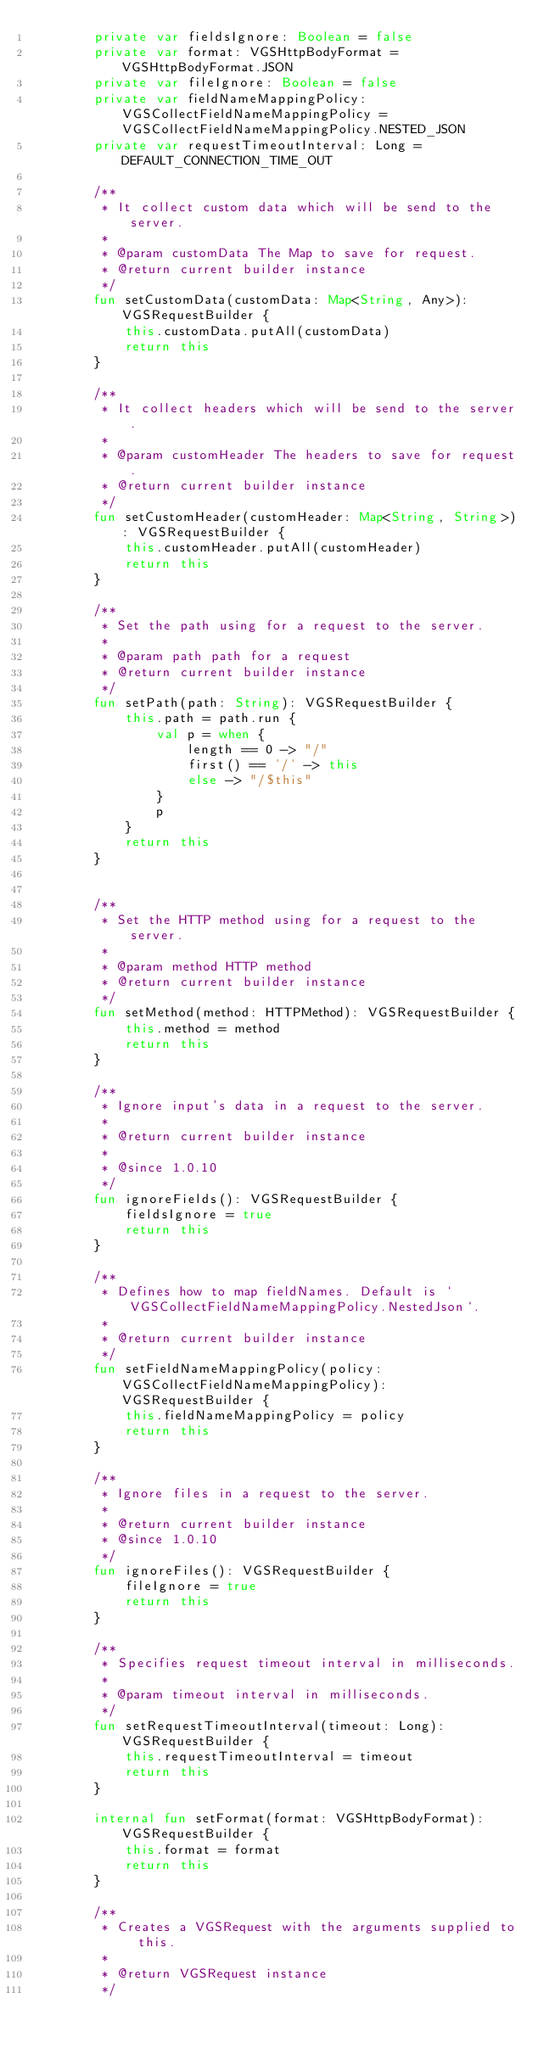Convert code to text. <code><loc_0><loc_0><loc_500><loc_500><_Kotlin_>        private var fieldsIgnore: Boolean = false
        private var format: VGSHttpBodyFormat = VGSHttpBodyFormat.JSON
        private var fileIgnore: Boolean = false
        private var fieldNameMappingPolicy: VGSCollectFieldNameMappingPolicy = VGSCollectFieldNameMappingPolicy.NESTED_JSON
        private var requestTimeoutInterval: Long = DEFAULT_CONNECTION_TIME_OUT

        /**
         * It collect custom data which will be send to the server.
         *
         * @param customData The Map to save for request.
         * @return current builder instance
         */
        fun setCustomData(customData: Map<String, Any>): VGSRequestBuilder {
            this.customData.putAll(customData)
            return this
        }

        /**
         * It collect headers which will be send to the server.
         *
         * @param customHeader The headers to save for request.
         * @return current builder instance
         */
        fun setCustomHeader(customHeader: Map<String, String>): VGSRequestBuilder {
            this.customHeader.putAll(customHeader)
            return this
        }

        /**
         * Set the path using for a request to the server.
         *
         * @param path path for a request
         * @return current builder instance
         */
        fun setPath(path: String): VGSRequestBuilder {
            this.path = path.run {
                val p = when {
                    length == 0 -> "/"
                    first() == '/' -> this
                    else -> "/$this"
                }
                p
            }
            return this
        }


        /**
         * Set the HTTP method using for a request to the server.
         *
         * @param method HTTP method
         * @return current builder instance
         */
        fun setMethod(method: HTTPMethod): VGSRequestBuilder {
            this.method = method
            return this
        }

        /**
         * Ignore input's data in a request to the server.
         *
         * @return current builder instance
         *
         * @since 1.0.10
         */
        fun ignoreFields(): VGSRequestBuilder {
            fieldsIgnore = true
            return this
        }

        /**
         * Defines how to map fieldNames. Default is `VGSCollectFieldNameMappingPolicy.NestedJson`.
         *
         * @return current builder instance
         */
        fun setFieldNameMappingPolicy(policy: VGSCollectFieldNameMappingPolicy): VGSRequestBuilder {
            this.fieldNameMappingPolicy = policy
            return this
        }

        /**
         * Ignore files in a request to the server.
         *
         * @return current builder instance
         * @since 1.0.10
         */
        fun ignoreFiles(): VGSRequestBuilder {
            fileIgnore = true
            return this
        }

        /**
         * Specifies request timeout interval in milliseconds.
         *
         * @param timeout interval in milliseconds.
         */
        fun setRequestTimeoutInterval(timeout: Long): VGSRequestBuilder {
            this.requestTimeoutInterval = timeout
            return this
        }

        internal fun setFormat(format: VGSHttpBodyFormat): VGSRequestBuilder {
            this.format = format
            return this
        }

        /**
         * Creates a VGSRequest with the arguments supplied to this.
         *
         * @return VGSRequest instance
         */</code> 